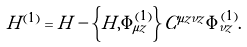<formula> <loc_0><loc_0><loc_500><loc_500>H ^ { ( 1 ) } = H - \left \{ H , \Phi ^ { ( 1 ) } _ { \mu z } \right \} C ^ { \mu z \nu z } \Phi ^ { ( 1 ) } _ { \nu z } .</formula> 